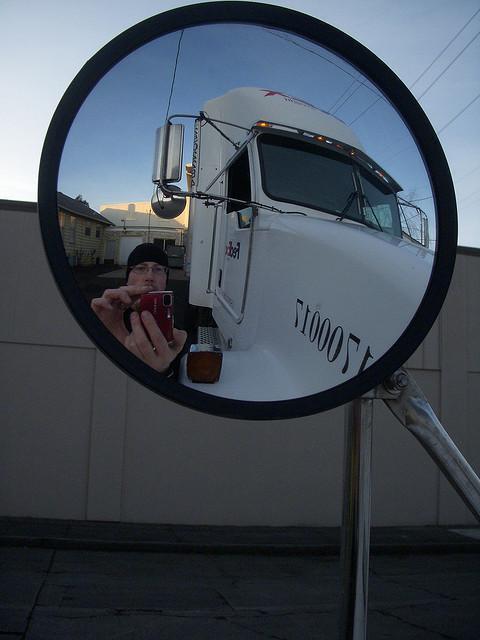Is the given caption "The truck is at the right side of the person." fitting for the image?
Answer yes or no. Yes. 